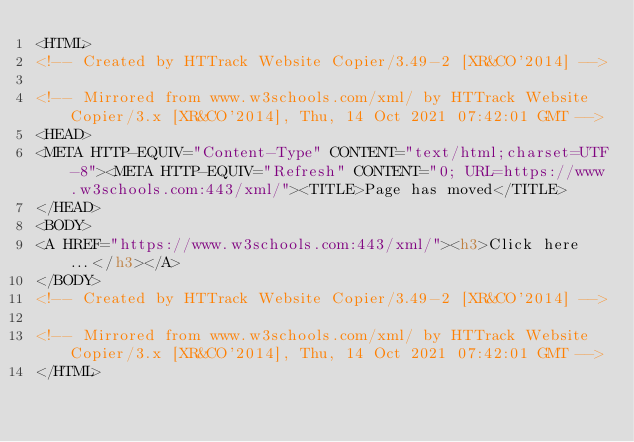<code> <loc_0><loc_0><loc_500><loc_500><_HTML_><HTML>
<!-- Created by HTTrack Website Copier/3.49-2 [XR&CO'2014] -->

<!-- Mirrored from www.w3schools.com/xml/ by HTTrack Website Copier/3.x [XR&CO'2014], Thu, 14 Oct 2021 07:42:01 GMT -->
<HEAD>
<META HTTP-EQUIV="Content-Type" CONTENT="text/html;charset=UTF-8"><META HTTP-EQUIV="Refresh" CONTENT="0; URL=https://www.w3schools.com:443/xml/"><TITLE>Page has moved</TITLE>
</HEAD>
<BODY>
<A HREF="https://www.w3schools.com:443/xml/"><h3>Click here...</h3></A>
</BODY>
<!-- Created by HTTrack Website Copier/3.49-2 [XR&CO'2014] -->

<!-- Mirrored from www.w3schools.com/xml/ by HTTrack Website Copier/3.x [XR&CO'2014], Thu, 14 Oct 2021 07:42:01 GMT -->
</HTML>
</code> 